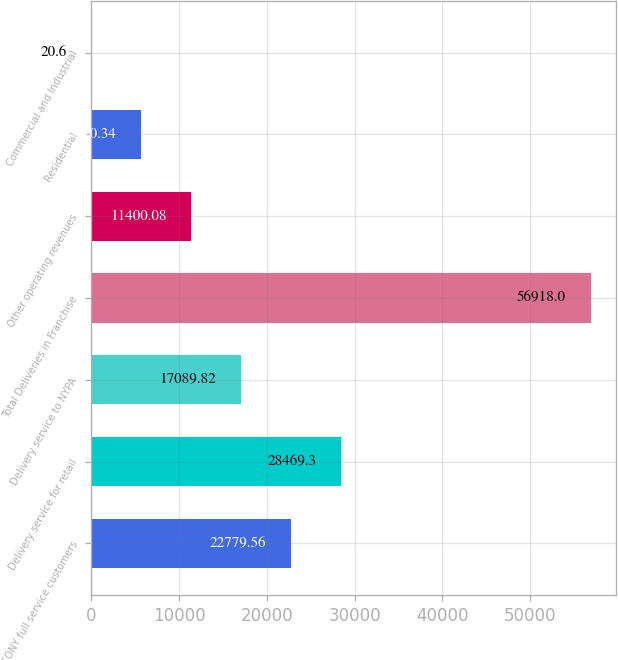Convert chart. <chart><loc_0><loc_0><loc_500><loc_500><bar_chart><fcel>CECONY full service customers<fcel>Delivery service for retail<fcel>Delivery service to NYPA<fcel>Total Deliveries in Franchise<fcel>Other operating revenues<fcel>Residential<fcel>Commercial and Industrial<nl><fcel>22779.6<fcel>28469.3<fcel>17089.8<fcel>56918<fcel>11400.1<fcel>5710.34<fcel>20.6<nl></chart> 